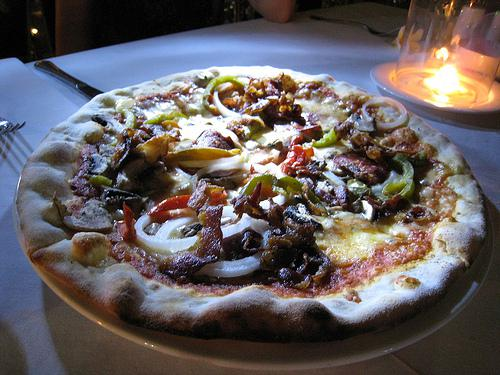Question: what is the food?
Choices:
A. Hamburger.
B. Pizza.
C. Potato.
D. Chicken.
Answer with the letter. Answer: B Question: what is the light in the background?
Choices:
A. Lamp.
B. A candle.
C. Headlight.
D. Television.
Answer with the letter. Answer: B Question: where is the plate sitting?
Choices:
A. Floor.
B. On the table.
C. Sink.
D. Table.
Answer with the letter. Answer: B Question: how many candles are in the picture?
Choices:
A. Two.
B. Three.
C. One.
D. Four.
Answer with the letter. Answer: C 